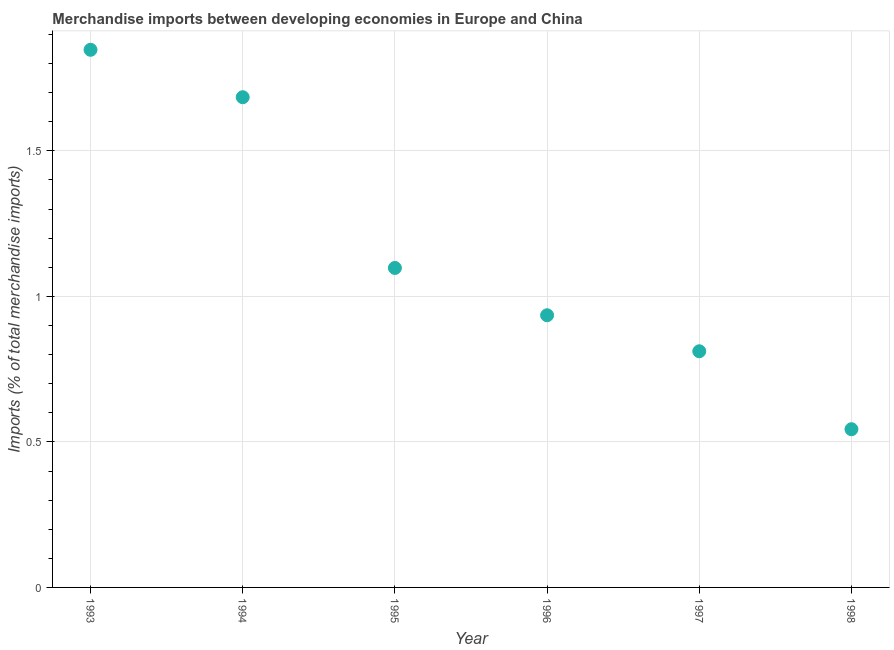What is the merchandise imports in 1996?
Your answer should be very brief. 0.94. Across all years, what is the maximum merchandise imports?
Give a very brief answer. 1.85. Across all years, what is the minimum merchandise imports?
Ensure brevity in your answer.  0.54. In which year was the merchandise imports minimum?
Your response must be concise. 1998. What is the sum of the merchandise imports?
Offer a terse response. 6.92. What is the difference between the merchandise imports in 1994 and 1996?
Give a very brief answer. 0.75. What is the average merchandise imports per year?
Ensure brevity in your answer.  1.15. What is the median merchandise imports?
Your answer should be very brief. 1.02. In how many years, is the merchandise imports greater than 0.7 %?
Make the answer very short. 5. Do a majority of the years between 1996 and 1993 (inclusive) have merchandise imports greater than 1.4 %?
Give a very brief answer. Yes. What is the ratio of the merchandise imports in 1994 to that in 1995?
Give a very brief answer. 1.53. Is the merchandise imports in 1993 less than that in 1996?
Your response must be concise. No. Is the difference between the merchandise imports in 1993 and 1997 greater than the difference between any two years?
Offer a very short reply. No. What is the difference between the highest and the second highest merchandise imports?
Provide a succinct answer. 0.16. What is the difference between the highest and the lowest merchandise imports?
Ensure brevity in your answer.  1.3. How many years are there in the graph?
Your answer should be very brief. 6. Are the values on the major ticks of Y-axis written in scientific E-notation?
Give a very brief answer. No. Does the graph contain any zero values?
Provide a short and direct response. No. What is the title of the graph?
Make the answer very short. Merchandise imports between developing economies in Europe and China. What is the label or title of the X-axis?
Provide a succinct answer. Year. What is the label or title of the Y-axis?
Your response must be concise. Imports (% of total merchandise imports). What is the Imports (% of total merchandise imports) in 1993?
Offer a terse response. 1.85. What is the Imports (% of total merchandise imports) in 1994?
Keep it short and to the point. 1.68. What is the Imports (% of total merchandise imports) in 1995?
Provide a succinct answer. 1.1. What is the Imports (% of total merchandise imports) in 1996?
Keep it short and to the point. 0.94. What is the Imports (% of total merchandise imports) in 1997?
Your answer should be very brief. 0.81. What is the Imports (% of total merchandise imports) in 1998?
Your answer should be compact. 0.54. What is the difference between the Imports (% of total merchandise imports) in 1993 and 1994?
Give a very brief answer. 0.16. What is the difference between the Imports (% of total merchandise imports) in 1993 and 1995?
Make the answer very short. 0.75. What is the difference between the Imports (% of total merchandise imports) in 1993 and 1996?
Give a very brief answer. 0.91. What is the difference between the Imports (% of total merchandise imports) in 1993 and 1997?
Offer a very short reply. 1.04. What is the difference between the Imports (% of total merchandise imports) in 1993 and 1998?
Give a very brief answer. 1.3. What is the difference between the Imports (% of total merchandise imports) in 1994 and 1995?
Your response must be concise. 0.59. What is the difference between the Imports (% of total merchandise imports) in 1994 and 1996?
Ensure brevity in your answer.  0.75. What is the difference between the Imports (% of total merchandise imports) in 1994 and 1997?
Keep it short and to the point. 0.87. What is the difference between the Imports (% of total merchandise imports) in 1994 and 1998?
Your response must be concise. 1.14. What is the difference between the Imports (% of total merchandise imports) in 1995 and 1996?
Keep it short and to the point. 0.16. What is the difference between the Imports (% of total merchandise imports) in 1995 and 1997?
Offer a terse response. 0.29. What is the difference between the Imports (% of total merchandise imports) in 1995 and 1998?
Provide a short and direct response. 0.55. What is the difference between the Imports (% of total merchandise imports) in 1996 and 1997?
Your answer should be very brief. 0.12. What is the difference between the Imports (% of total merchandise imports) in 1996 and 1998?
Your answer should be compact. 0.39. What is the difference between the Imports (% of total merchandise imports) in 1997 and 1998?
Your answer should be very brief. 0.27. What is the ratio of the Imports (% of total merchandise imports) in 1993 to that in 1994?
Ensure brevity in your answer.  1.1. What is the ratio of the Imports (% of total merchandise imports) in 1993 to that in 1995?
Your answer should be compact. 1.68. What is the ratio of the Imports (% of total merchandise imports) in 1993 to that in 1996?
Keep it short and to the point. 1.98. What is the ratio of the Imports (% of total merchandise imports) in 1993 to that in 1997?
Keep it short and to the point. 2.28. What is the ratio of the Imports (% of total merchandise imports) in 1993 to that in 1998?
Your answer should be compact. 3.4. What is the ratio of the Imports (% of total merchandise imports) in 1994 to that in 1995?
Make the answer very short. 1.53. What is the ratio of the Imports (% of total merchandise imports) in 1994 to that in 1996?
Provide a succinct answer. 1.8. What is the ratio of the Imports (% of total merchandise imports) in 1994 to that in 1997?
Offer a terse response. 2.08. What is the ratio of the Imports (% of total merchandise imports) in 1994 to that in 1998?
Keep it short and to the point. 3.1. What is the ratio of the Imports (% of total merchandise imports) in 1995 to that in 1996?
Make the answer very short. 1.17. What is the ratio of the Imports (% of total merchandise imports) in 1995 to that in 1997?
Keep it short and to the point. 1.35. What is the ratio of the Imports (% of total merchandise imports) in 1995 to that in 1998?
Ensure brevity in your answer.  2.02. What is the ratio of the Imports (% of total merchandise imports) in 1996 to that in 1997?
Your answer should be very brief. 1.15. What is the ratio of the Imports (% of total merchandise imports) in 1996 to that in 1998?
Provide a succinct answer. 1.72. What is the ratio of the Imports (% of total merchandise imports) in 1997 to that in 1998?
Ensure brevity in your answer.  1.49. 